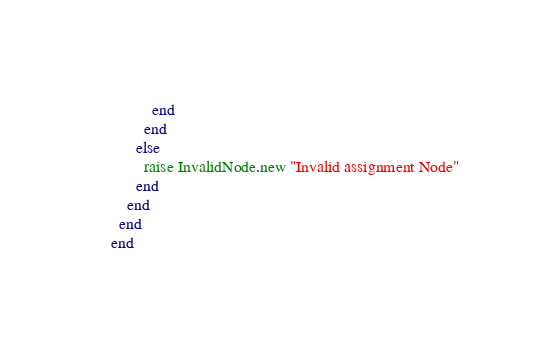<code> <loc_0><loc_0><loc_500><loc_500><_Crystal_>          end
        end
      else
        raise InvalidNode.new "Invalid assignment Node"
      end
    end
  end
end
</code> 